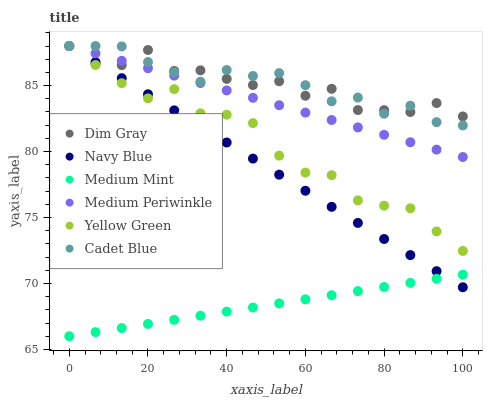Does Medium Mint have the minimum area under the curve?
Answer yes or no. Yes. Does Cadet Blue have the maximum area under the curve?
Answer yes or no. Yes. Does Dim Gray have the minimum area under the curve?
Answer yes or no. No. Does Dim Gray have the maximum area under the curve?
Answer yes or no. No. Is Navy Blue the smoothest?
Answer yes or no. Yes. Is Dim Gray the roughest?
Answer yes or no. Yes. Is Yellow Green the smoothest?
Answer yes or no. No. Is Yellow Green the roughest?
Answer yes or no. No. Does Medium Mint have the lowest value?
Answer yes or no. Yes. Does Yellow Green have the lowest value?
Answer yes or no. No. Does Cadet Blue have the highest value?
Answer yes or no. Yes. Does Dim Gray have the highest value?
Answer yes or no. No. Is Medium Mint less than Cadet Blue?
Answer yes or no. Yes. Is Medium Periwinkle greater than Medium Mint?
Answer yes or no. Yes. Does Medium Periwinkle intersect Dim Gray?
Answer yes or no. Yes. Is Medium Periwinkle less than Dim Gray?
Answer yes or no. No. Is Medium Periwinkle greater than Dim Gray?
Answer yes or no. No. Does Medium Mint intersect Cadet Blue?
Answer yes or no. No. 